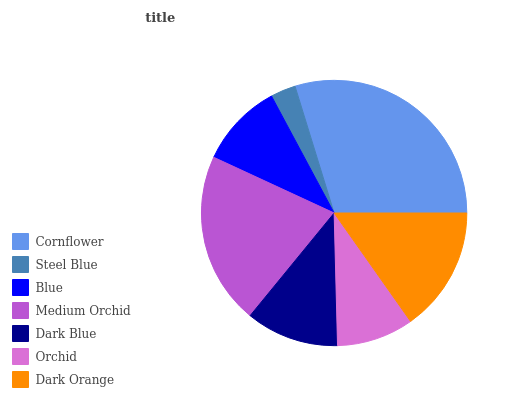Is Steel Blue the minimum?
Answer yes or no. Yes. Is Cornflower the maximum?
Answer yes or no. Yes. Is Blue the minimum?
Answer yes or no. No. Is Blue the maximum?
Answer yes or no. No. Is Blue greater than Steel Blue?
Answer yes or no. Yes. Is Steel Blue less than Blue?
Answer yes or no. Yes. Is Steel Blue greater than Blue?
Answer yes or no. No. Is Blue less than Steel Blue?
Answer yes or no. No. Is Dark Blue the high median?
Answer yes or no. Yes. Is Dark Blue the low median?
Answer yes or no. Yes. Is Medium Orchid the high median?
Answer yes or no. No. Is Blue the low median?
Answer yes or no. No. 